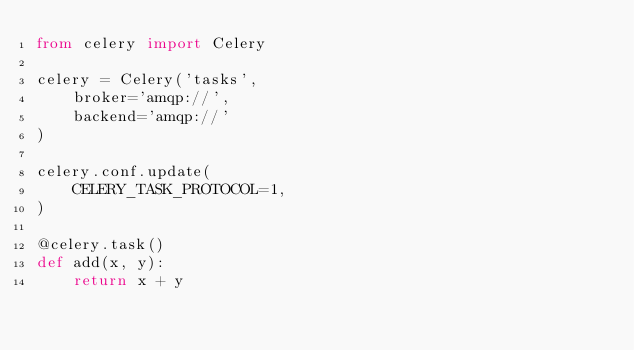<code> <loc_0><loc_0><loc_500><loc_500><_Python_>from celery import Celery

celery = Celery('tasks', 
    broker='amqp://',
    backend='amqp://'
)

celery.conf.update(
    CELERY_TASK_PROTOCOL=1,
)

@celery.task()
def add(x, y):
    return x + y
</code> 